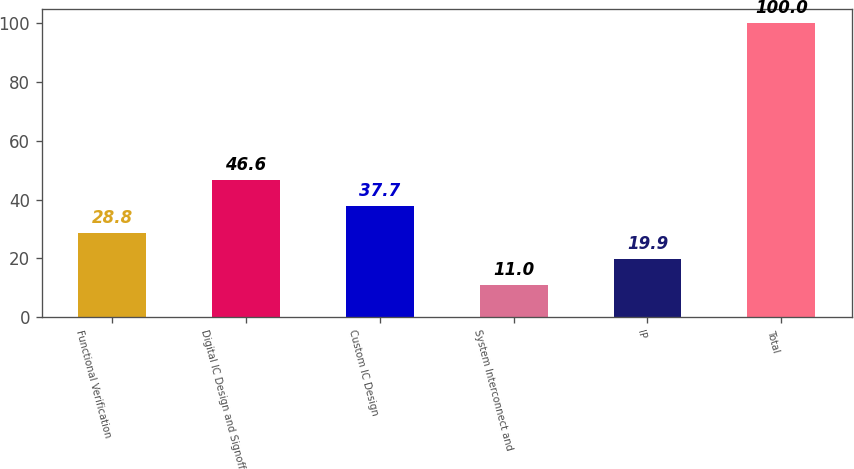Convert chart to OTSL. <chart><loc_0><loc_0><loc_500><loc_500><bar_chart><fcel>Functional Verification<fcel>Digital IC Design and Signoff<fcel>Custom IC Design<fcel>System Interconnect and<fcel>IP<fcel>Total<nl><fcel>28.8<fcel>46.6<fcel>37.7<fcel>11<fcel>19.9<fcel>100<nl></chart> 